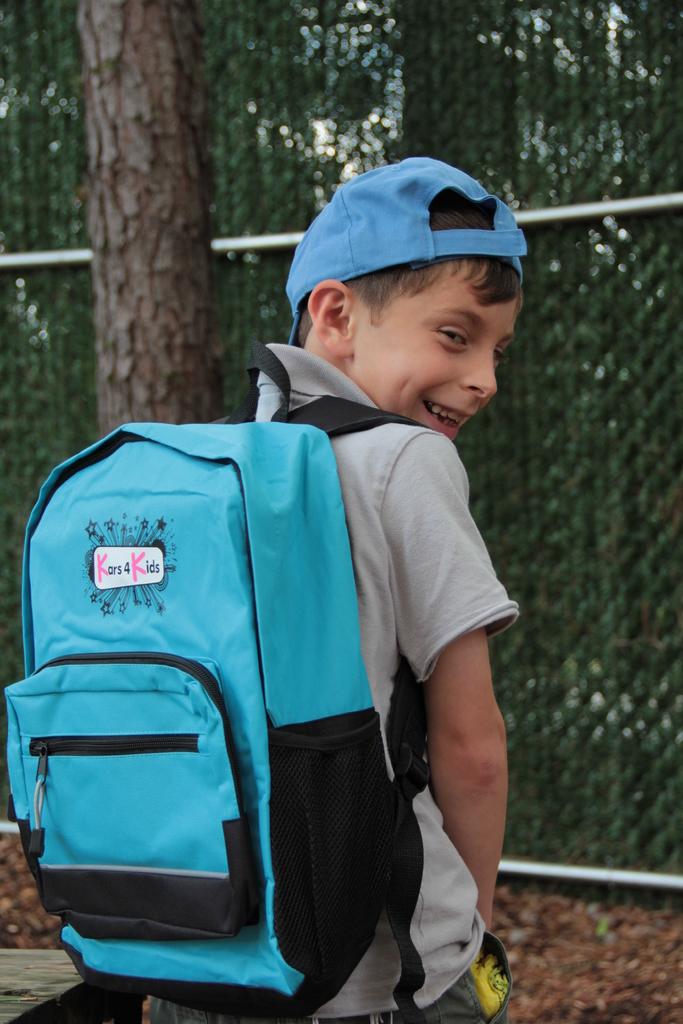What brand is the book bag?
Offer a very short reply. Kars 4 kids. 